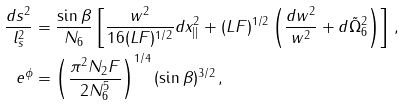<formula> <loc_0><loc_0><loc_500><loc_500>\frac { d s ^ { 2 } } { l _ { s } ^ { 2 } } & = \frac { \sin \beta } { N _ { 6 } } \left [ \frac { w ^ { 2 } } { 1 6 ( L F ) ^ { 1 / 2 } } d x ^ { 2 } _ { | | } + ( L F ) ^ { 1 / 2 } \left ( \frac { d w ^ { 2 } } { w ^ { 2 } } + d \tilde { \Omega } _ { 6 } ^ { 2 } \right ) \right ] \, , \\ e ^ { \phi } & = \left ( \frac { \pi ^ { 2 } N _ { 2 } F } { 2 N _ { 6 } ^ { 5 } } \right ) ^ { 1 / 4 } ( \sin \beta ) ^ { 3 / 2 } \, ,</formula> 